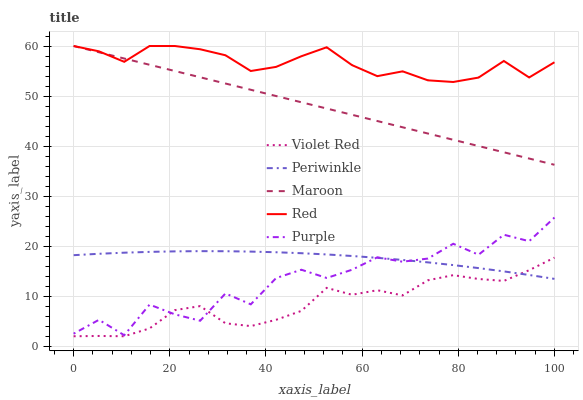Does Violet Red have the minimum area under the curve?
Answer yes or no. Yes. Does Red have the maximum area under the curve?
Answer yes or no. Yes. Does Periwinkle have the minimum area under the curve?
Answer yes or no. No. Does Periwinkle have the maximum area under the curve?
Answer yes or no. No. Is Maroon the smoothest?
Answer yes or no. Yes. Is Purple the roughest?
Answer yes or no. Yes. Is Violet Red the smoothest?
Answer yes or no. No. Is Violet Red the roughest?
Answer yes or no. No. Does Periwinkle have the lowest value?
Answer yes or no. No. Does Periwinkle have the highest value?
Answer yes or no. No. Is Purple less than Maroon?
Answer yes or no. Yes. Is Red greater than Periwinkle?
Answer yes or no. Yes. Does Purple intersect Maroon?
Answer yes or no. No. 